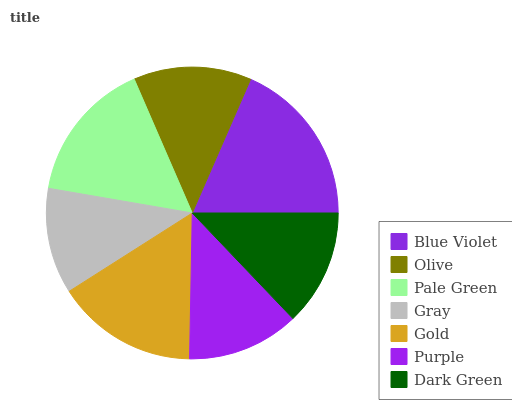Is Gray the minimum?
Answer yes or no. Yes. Is Blue Violet the maximum?
Answer yes or no. Yes. Is Olive the minimum?
Answer yes or no. No. Is Olive the maximum?
Answer yes or no. No. Is Blue Violet greater than Olive?
Answer yes or no. Yes. Is Olive less than Blue Violet?
Answer yes or no. Yes. Is Olive greater than Blue Violet?
Answer yes or no. No. Is Blue Violet less than Olive?
Answer yes or no. No. Is Olive the high median?
Answer yes or no. Yes. Is Olive the low median?
Answer yes or no. Yes. Is Pale Green the high median?
Answer yes or no. No. Is Blue Violet the low median?
Answer yes or no. No. 